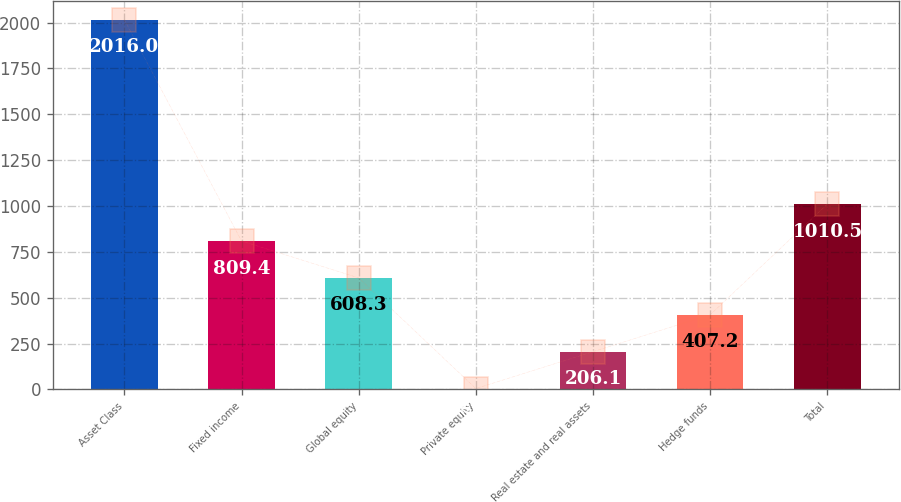Convert chart to OTSL. <chart><loc_0><loc_0><loc_500><loc_500><bar_chart><fcel>Asset Class<fcel>Fixed income<fcel>Global equity<fcel>Private equity<fcel>Real estate and real assets<fcel>Hedge funds<fcel>Total<nl><fcel>2016<fcel>809.4<fcel>608.3<fcel>5<fcel>206.1<fcel>407.2<fcel>1010.5<nl></chart> 